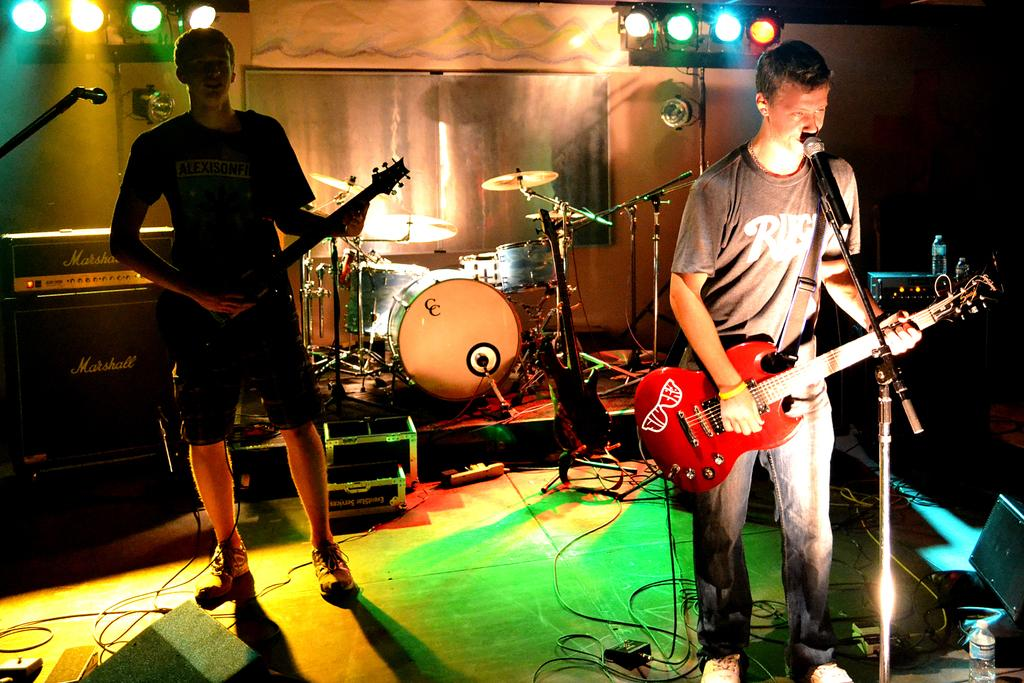Who or what can be seen in the image? There are people in the image. What are the people doing in the image? The people are standing and holding guitars in their hands. Are there any other musical instruments visible in the image? Yes, there are other musical instruments visible in the background. What type of bed can be seen in the image? There is no bed present in the image. Are the people in the image sleeping? No, the people in the image are standing and holding guitars, so they are not sleeping. 